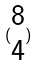Convert formula to latex. <formula><loc_0><loc_0><loc_500><loc_500>( \begin{matrix} 8 \\ 4 \end{matrix} )</formula> 